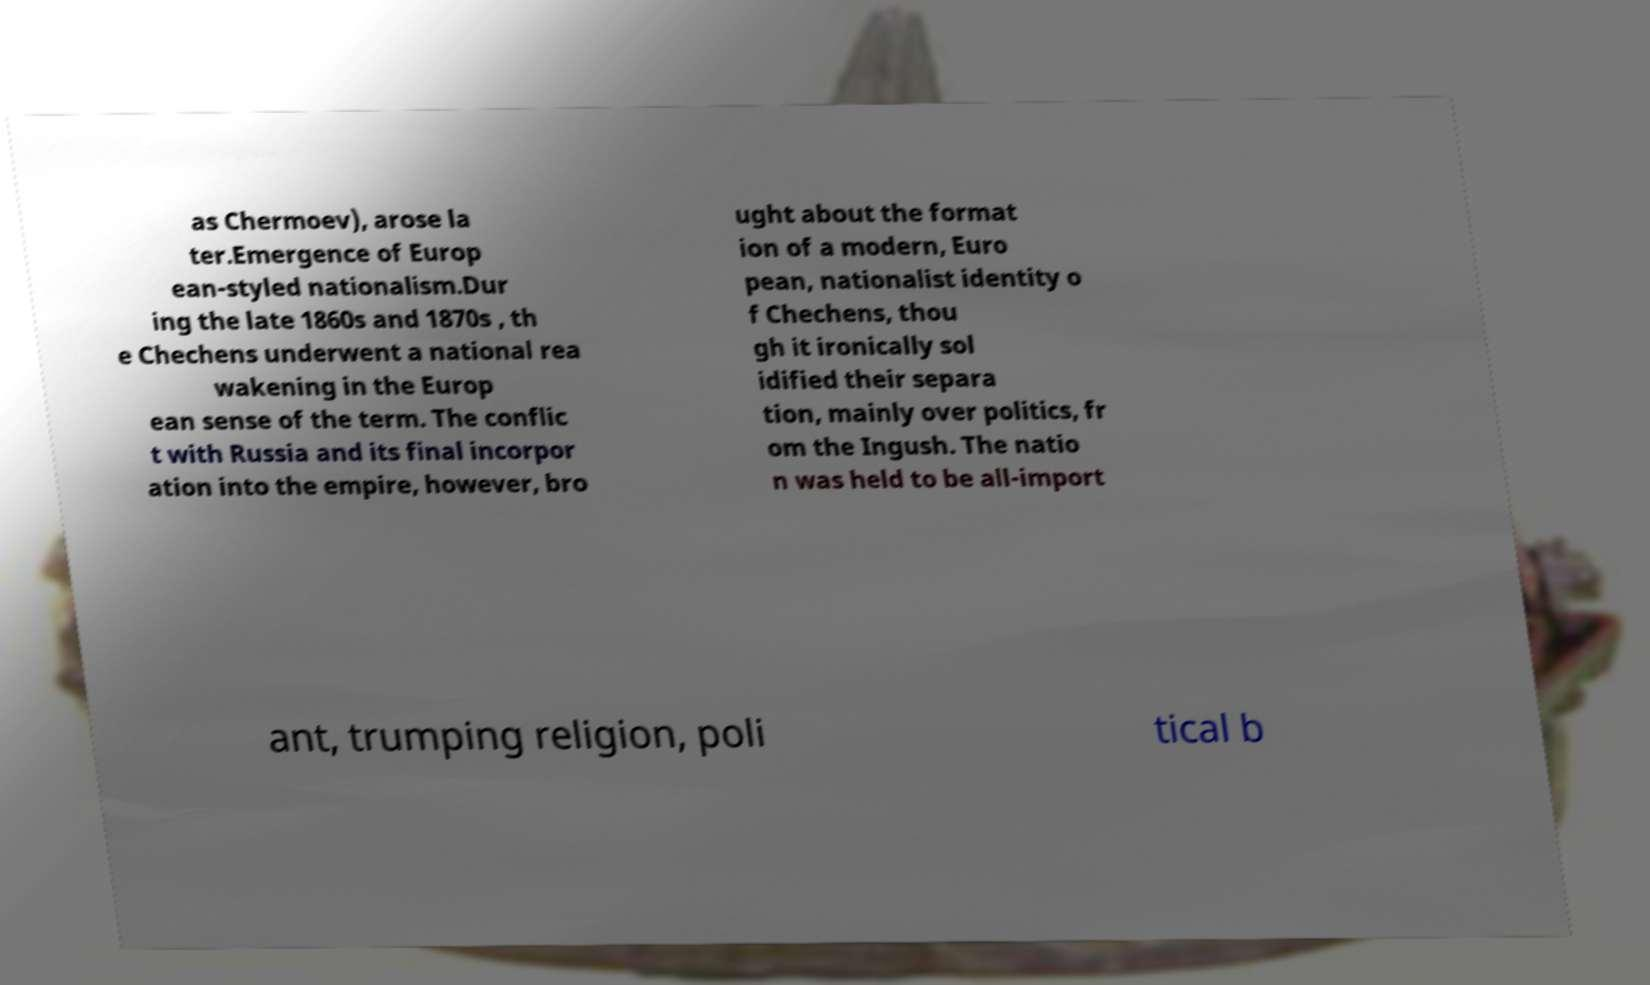What messages or text are displayed in this image? I need them in a readable, typed format. as Chermoev), arose la ter.Emergence of Europ ean-styled nationalism.Dur ing the late 1860s and 1870s , th e Chechens underwent a national rea wakening in the Europ ean sense of the term. The conflic t with Russia and its final incorpor ation into the empire, however, bro ught about the format ion of a modern, Euro pean, nationalist identity o f Chechens, thou gh it ironically sol idified their separa tion, mainly over politics, fr om the Ingush. The natio n was held to be all-import ant, trumping religion, poli tical b 